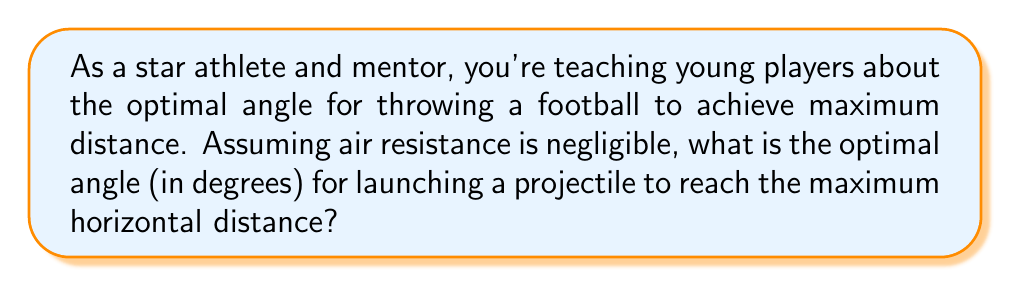Provide a solution to this math problem. To solve this problem, we need to understand the principles of projectile motion and use calculus to find the optimal angle. Let's break it down step by step:

1) The horizontal distance (range) of a projectile launched from ground level is given by the equation:

   $$R = \frac{v_0^2 \sin(2\theta)}{g}$$

   Where:
   $R$ is the range (horizontal distance)
   $v_0$ is the initial velocity
   $\theta$ is the launch angle
   $g$ is the acceleration due to gravity

2) To find the maximum range, we need to find the angle $\theta$ that maximizes this function. We can do this by taking the derivative of $R$ with respect to $\theta$ and setting it equal to zero:

   $$\frac{dR}{d\theta} = \frac{v_0^2}{g} \cdot 2\cos(2\theta) = 0$$

3) Solving this equation:

   $$2\cos(2\theta) = 0$$
   $$\cos(2\theta) = 0$$

4) The cosine function equals zero when its argument is $\frac{\pi}{2}$ (or 90°) plus any multiple of $\pi$. So:

   $$2\theta = \frac{\pi}{2} + n\pi$$

   Where $n$ is an integer.

5) Solving for $\theta$:

   $$\theta = \frac{\pi}{4} + \frac{n\pi}{2}$$

6) The smallest positive solution is when $n = 0$:

   $$\theta = \frac{\pi}{4}$$

7) Converting to degrees:

   $$\theta = \frac{\pi}{4} \cdot \frac{180°}{\pi} = 45°$$

Therefore, the optimal angle for maximum distance in projectile motion is 45°.
Answer: 45° 